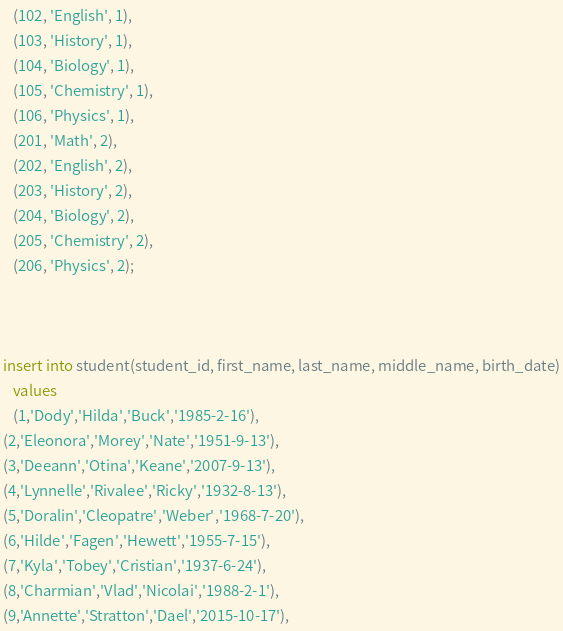Convert code to text. <code><loc_0><loc_0><loc_500><loc_500><_SQL_>   (102, 'English', 1),
   (103, 'History', 1),
   (104, 'Biology', 1),
   (105, 'Chemistry', 1),
   (106, 'Physics', 1),
   (201, 'Math', 2),
   (202, 'English', 2),
   (203, 'History', 2),
   (204, 'Biology', 2),
   (205, 'Chemistry', 2),
   (206, 'Physics', 2);
   
   

insert into student(student_id, first_name, last_name, middle_name, birth_date)
   values
   (1,'Dody','Hilda','Buck','1985-2-16'),
(2,'Eleonora','Morey','Nate','1951-9-13'),
(3,'Deeann','Otina','Keane','2007-9-13'),
(4,'Lynnelle','Rivalee','Ricky','1932-8-13'),
(5,'Doralin','Cleopatre','Weber','1968-7-20'),
(6,'Hilde','Fagen','Hewett','1955-7-15'),
(7,'Kyla','Tobey','Cristian','1937-6-24'),
(8,'Charmian','Vlad','Nicolai','1988-2-1'),
(9,'Annette','Stratton','Dael','2015-10-17'),</code> 